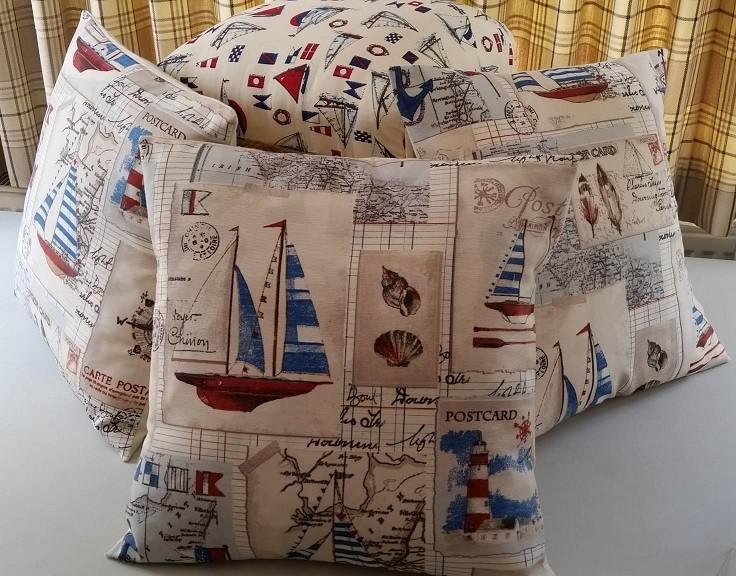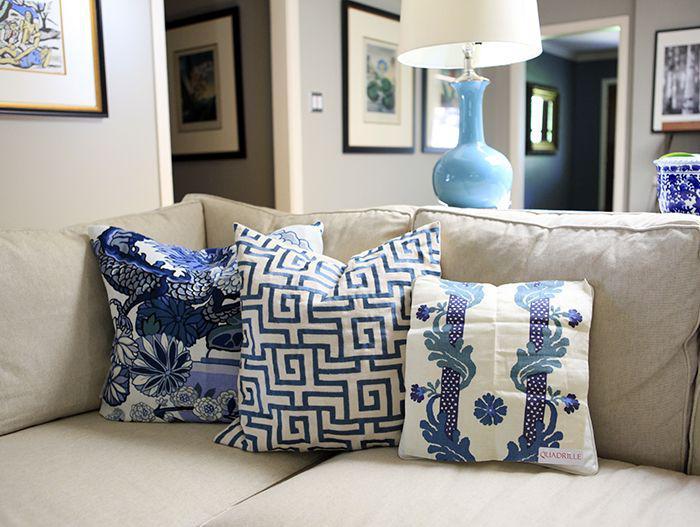The first image is the image on the left, the second image is the image on the right. For the images shown, is this caption "There are more pillows in the left image than in the right image." true? Answer yes or no. Yes. The first image is the image on the left, the second image is the image on the right. For the images displayed, is the sentence "There are there different pillows sitting in a row on top of a cream colored sofa." factually correct? Answer yes or no. Yes. 